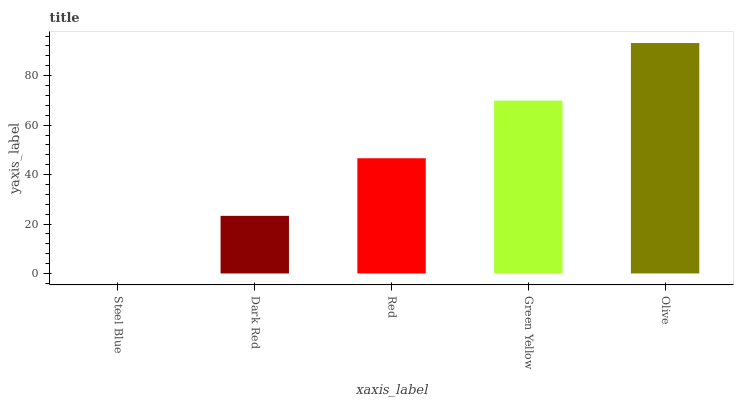Is Steel Blue the minimum?
Answer yes or no. Yes. Is Olive the maximum?
Answer yes or no. Yes. Is Dark Red the minimum?
Answer yes or no. No. Is Dark Red the maximum?
Answer yes or no. No. Is Dark Red greater than Steel Blue?
Answer yes or no. Yes. Is Steel Blue less than Dark Red?
Answer yes or no. Yes. Is Steel Blue greater than Dark Red?
Answer yes or no. No. Is Dark Red less than Steel Blue?
Answer yes or no. No. Is Red the high median?
Answer yes or no. Yes. Is Red the low median?
Answer yes or no. Yes. Is Olive the high median?
Answer yes or no. No. Is Dark Red the low median?
Answer yes or no. No. 